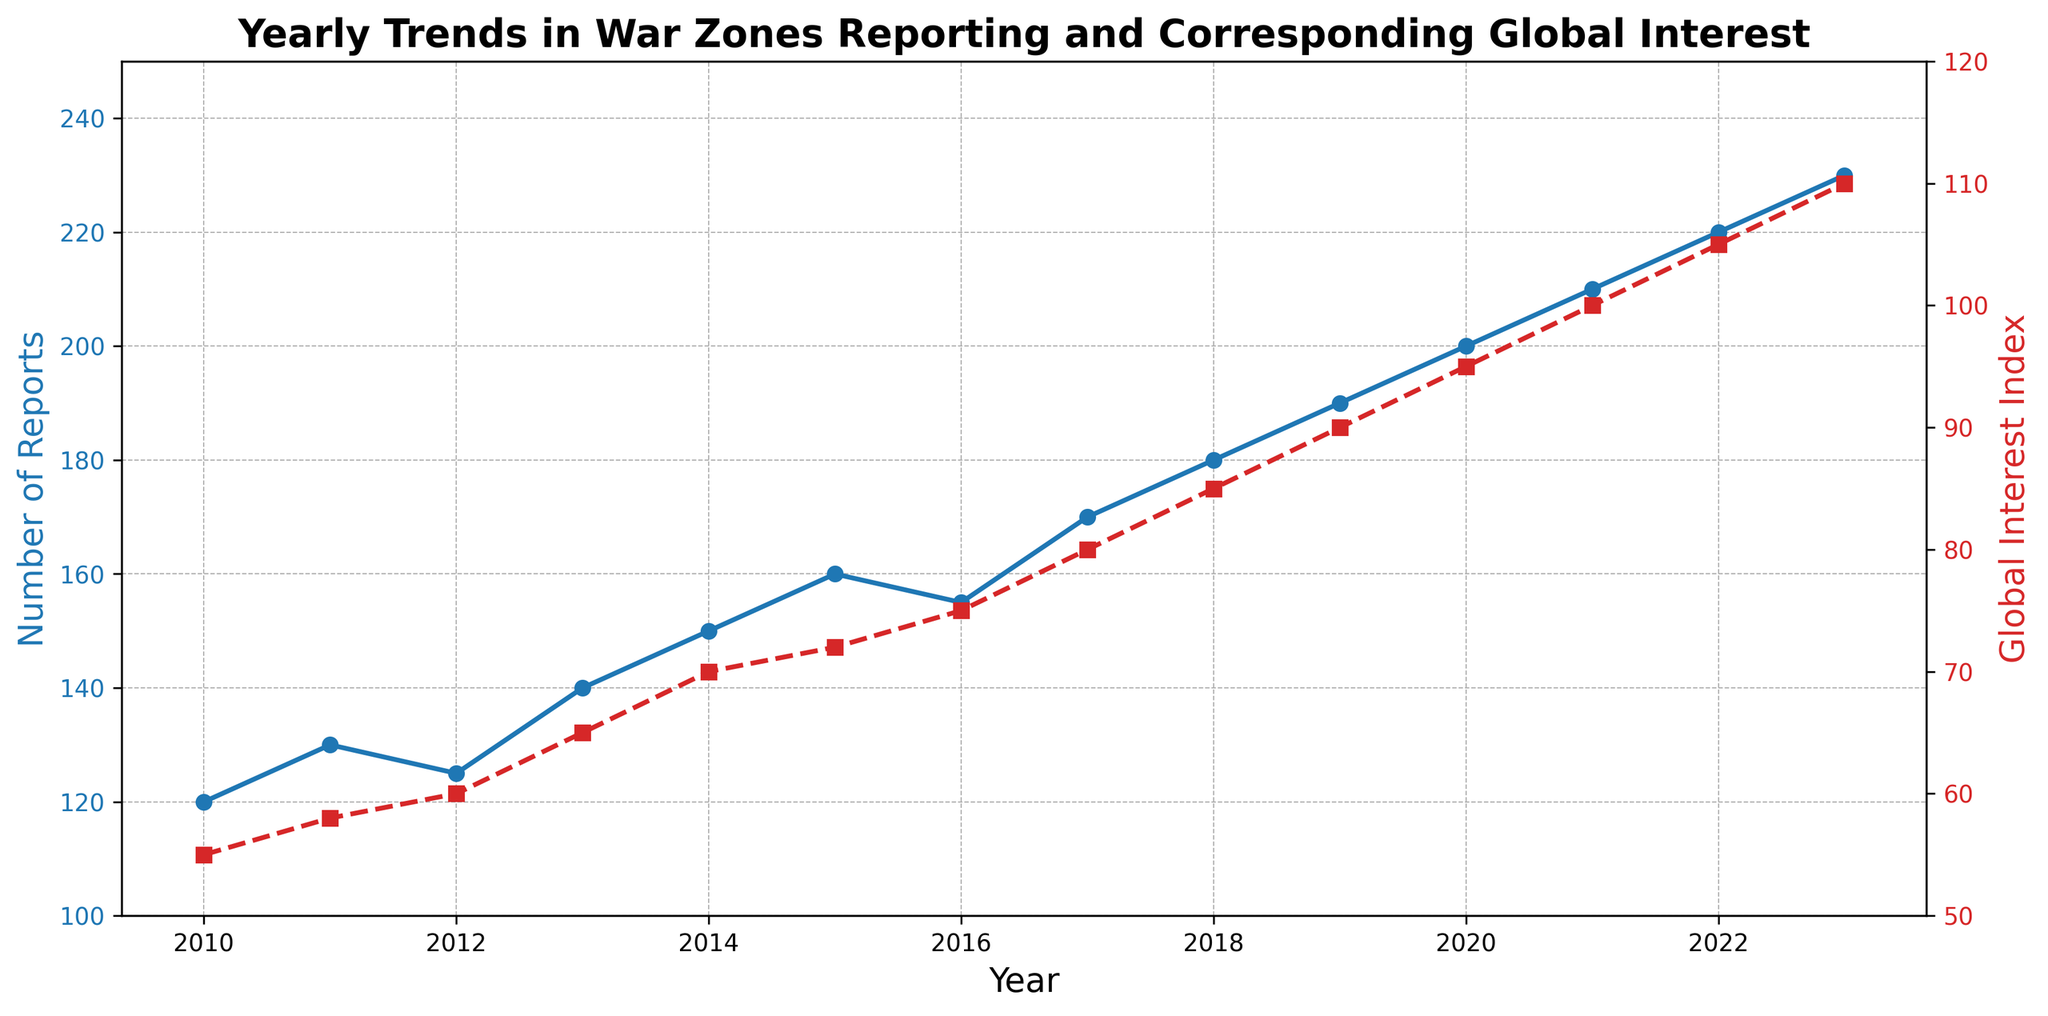What's the general trend in the Number of Reports from 2010 to 2023? Observing the blue line representing the Number of Reports, it shows a consistent upward trend from 2010 to 2023, increasing each year with minor fluctuations in certain years.
Answer: Increasing Between which years did the Global Interest Index increase by the greatest amount? The red line representing Global Interest Index shows the steepest increase between 2021 and 2022, where it jumps from 100 to 105, marking an increase of 5 points.
Answer: 2021 to 2022 In what year did both the Number of Reports and Global Interest Index first reach or exceed 200 and 95 respectively? Looking at both lines, in 2020, the Number of Reports reaches 200 and the Global Interest Index reaches 95.
Answer: 2020 How many reports were there in 2019, and what was the corresponding Global Interest Index? Refer to the blue and red lines for the year 2019, where the Number of Reports is 190, and the Global Interest Index is 90.
Answer: 190 reports and 90 Global Interest Index From 2015 to 2016, was there an increase or decrease in the Number of Reports, and by how much? The plot shows that the Number of Reports decreased from 160 in 2015 to 155 in 2016. The difference is calculated as 160 - 155 = 5.
Answer: Decrease by 5 Which year experienced the highest Global Interest Index? The red line peaks in 2023, reaching the highest Global Interest Index of 110.
Answer: 2023 What is the average Global Interest Index from 2010 to 2023? Add all the Global Interest Index values (55 + 58 + 60 + 65 + 70 + 72 + 75 + 80 + 85 + 90 + 95 + 100 + 105 + 110) and divide by the number of years (14). Total = 1120, so the average is 1120 / 14 ≈ 80.
Answer: Approximately 80 Compare the increment in the Number of Reports from 2010 to 2013 with the increment from 2020 to 2023. Which period had a higher increment? 2010 to 2013 increased from 120 to 140 (increment of 20). 2020 to 2023 increased from 200 to 230 (increment of 30).
Answer: 2020 to 2023 had a higher increment What color represents the Global Interest Index in the plot, and what is the style of its line? The red color represents the Global Interest Index, and its line style is dashed with square markers.
Answer: Red with dashed line and square markers Identify any year(s) where the Number of Reports remained the same as the previous year. The blue line does not show any completely horizontal segments, indicating the Number of Reports increased or decreased every year, but in 2012 it decreases back to 125 and remains the same as 2011.
Answer: 2012 